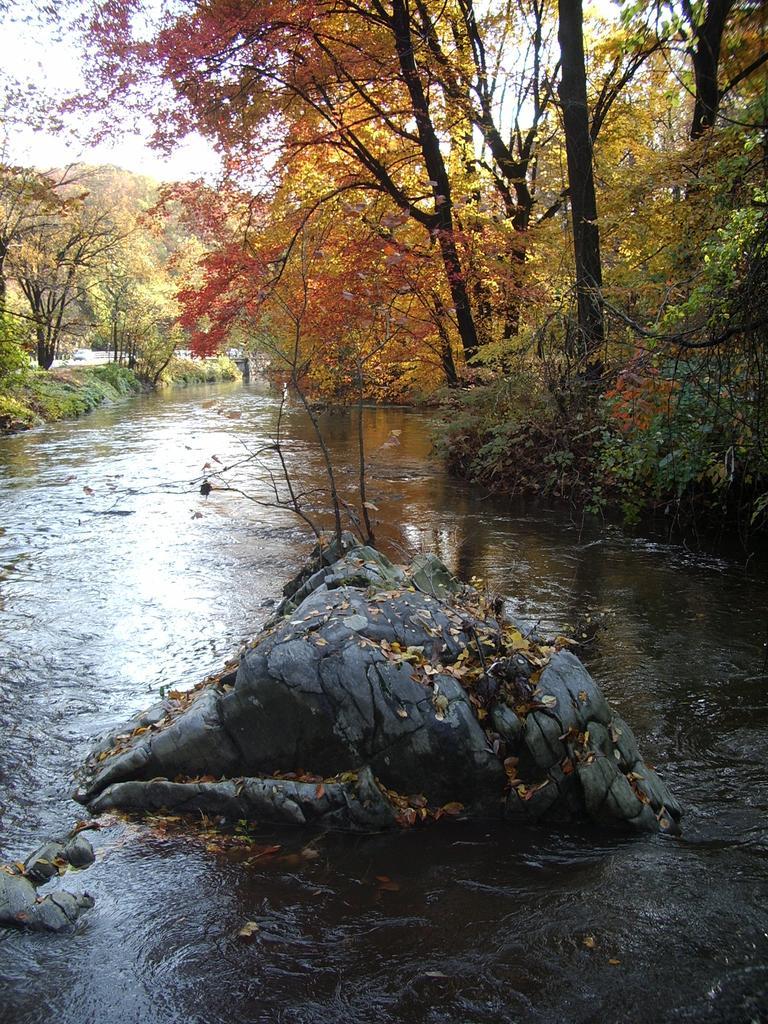Please provide a concise description of this image. In this picture we can see water, few rocks and trees. 